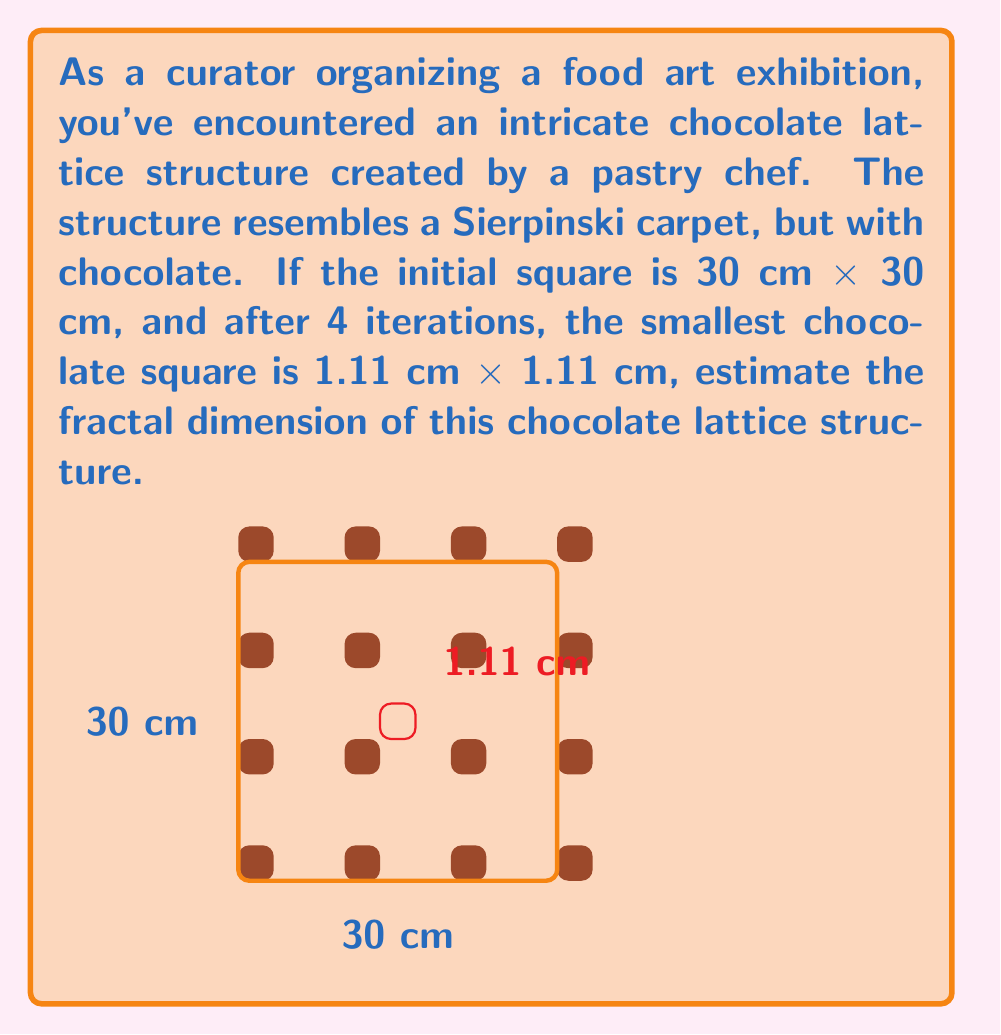Help me with this question. To estimate the fractal dimension of the chocolate lattice structure, we'll use the box-counting method. The fractal dimension $D$ is given by:

$$D = \frac{\log N}{\log (1/r)}$$

Where:
$N$ = number of self-similar pieces
$r$ = scale factor

Step 1: Determine the scale factor $r$
Initial size: 30 cm
Size after 4 iterations: 1.11 cm
$r = 1.11 / 30 = 0.037$

Step 2: Determine the number of self-similar pieces $N$
For a Sierpinski carpet-like structure:
$N = 8^4 = 4096$ (because in each iteration, we keep 8 out of 9 squares, and we have 4 iterations)

Step 3: Calculate the fractal dimension

$$\begin{aligned}
D &= \frac{\log N}{\log (1/r)} \\[10pt]
&= \frac{\log 4096}{\log (1/0.037)} \\[10pt]
&= \frac{\log 4096}{\log 27.027} \\[10pt]
&\approx 1.8928
\end{aligned}$$

Therefore, the estimated fractal dimension of the chocolate lattice structure is approximately 1.8928.
Answer: $D \approx 1.8928$ 